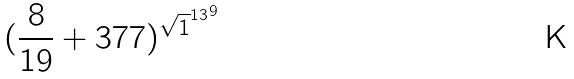Convert formula to latex. <formula><loc_0><loc_0><loc_500><loc_500>( \frac { 8 } { 1 9 } + 3 7 7 ) ^ { { \sqrt { 1 } ^ { 1 3 } } ^ { 9 } }</formula> 